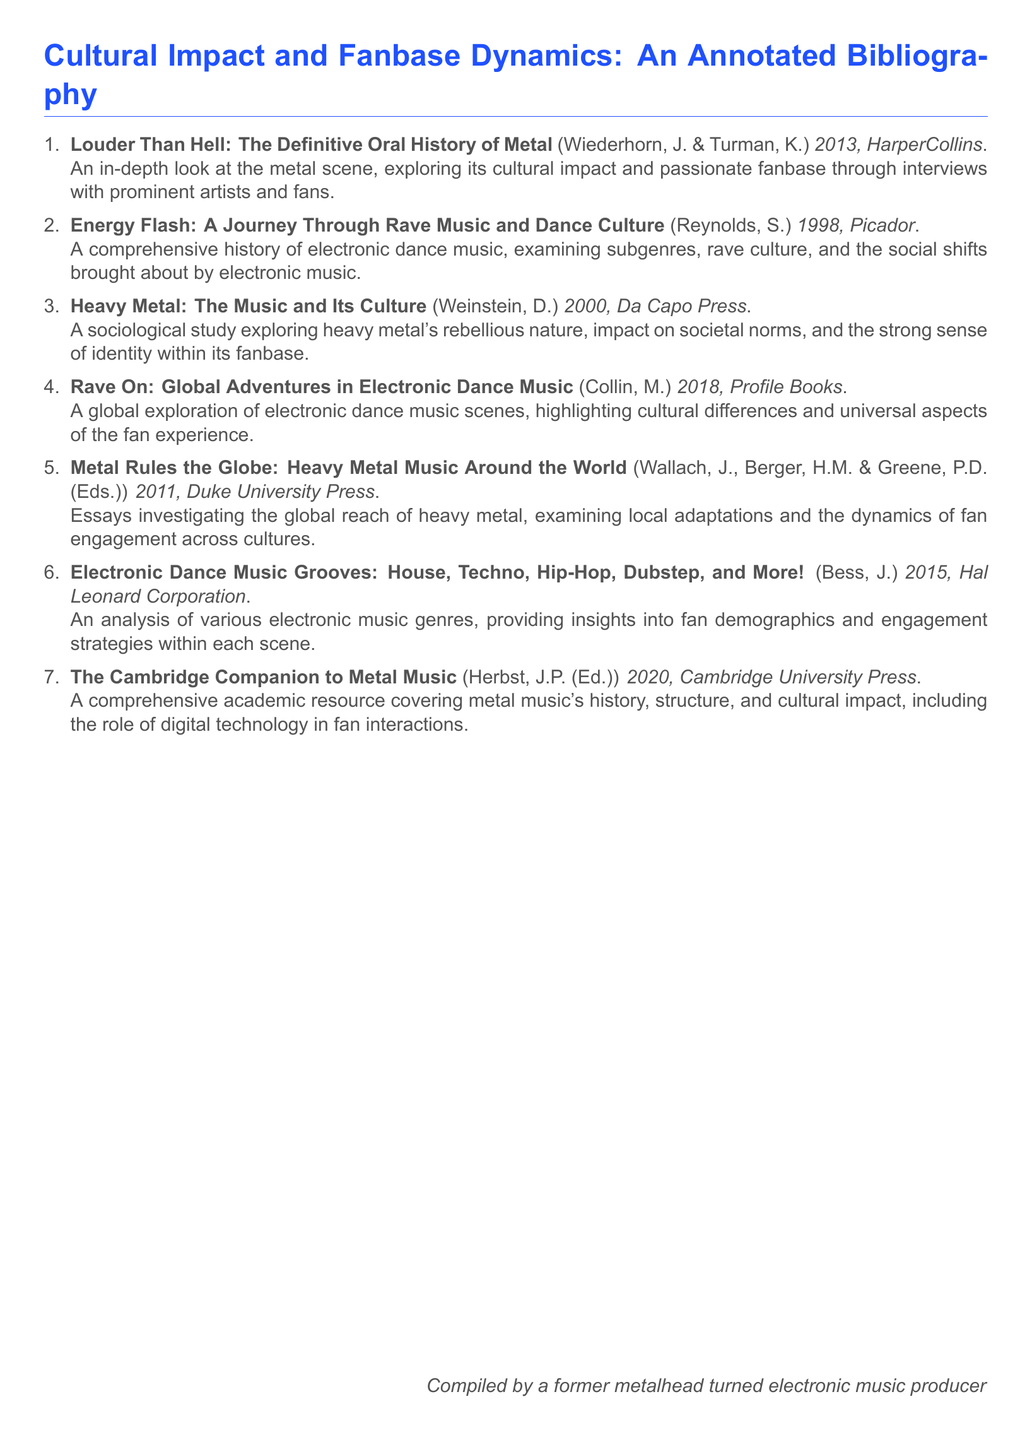What is the title of the first entry? The title of the first entry is taken directly from the document, which is "Louder Than Hell: The Definitive Oral History of Metal."
Answer: Louder Than Hell: The Definitive Oral History of Metal Who are the authors of the second entry? The authors of the second entry, as listed in the document, are S. Reynolds.
Answer: S. Reynolds In what year was "Metal Rules the Globe" published? The year of publication is explicitly mentioned in the entry for "Metal Rules the Globe," which is 2011.
Answer: 2011 What type of document is this? This document is specifically a type of Bibliography focusing on cultural impacts and fanbase dynamics in music.
Answer: An Annotated Bibliography How many authors contributed to "The Cambridge Companion to Metal Music"? The number of authors is derived from the document, where the work has one contributing editor, J.P. Herbst.
Answer: One What is the main focus of the book "Energy Flash"? The main focus of the book "Energy Flash" is stated in the document, which examines rave culture and social shifts in music.
Answer: Rave culture Which book explores global adaptations of heavy metal? The book that explores this topic is explicitly mentioned in the bibliography entry for "Metal Rules the Globe."
Answer: Metal Rules the Globe What genre of music is analyzed in "Electronic Dance Music Grooves"? The genre of music analyzed in this entry focuses on various electronic music genres as identified in the document.
Answer: Electronic music genres 